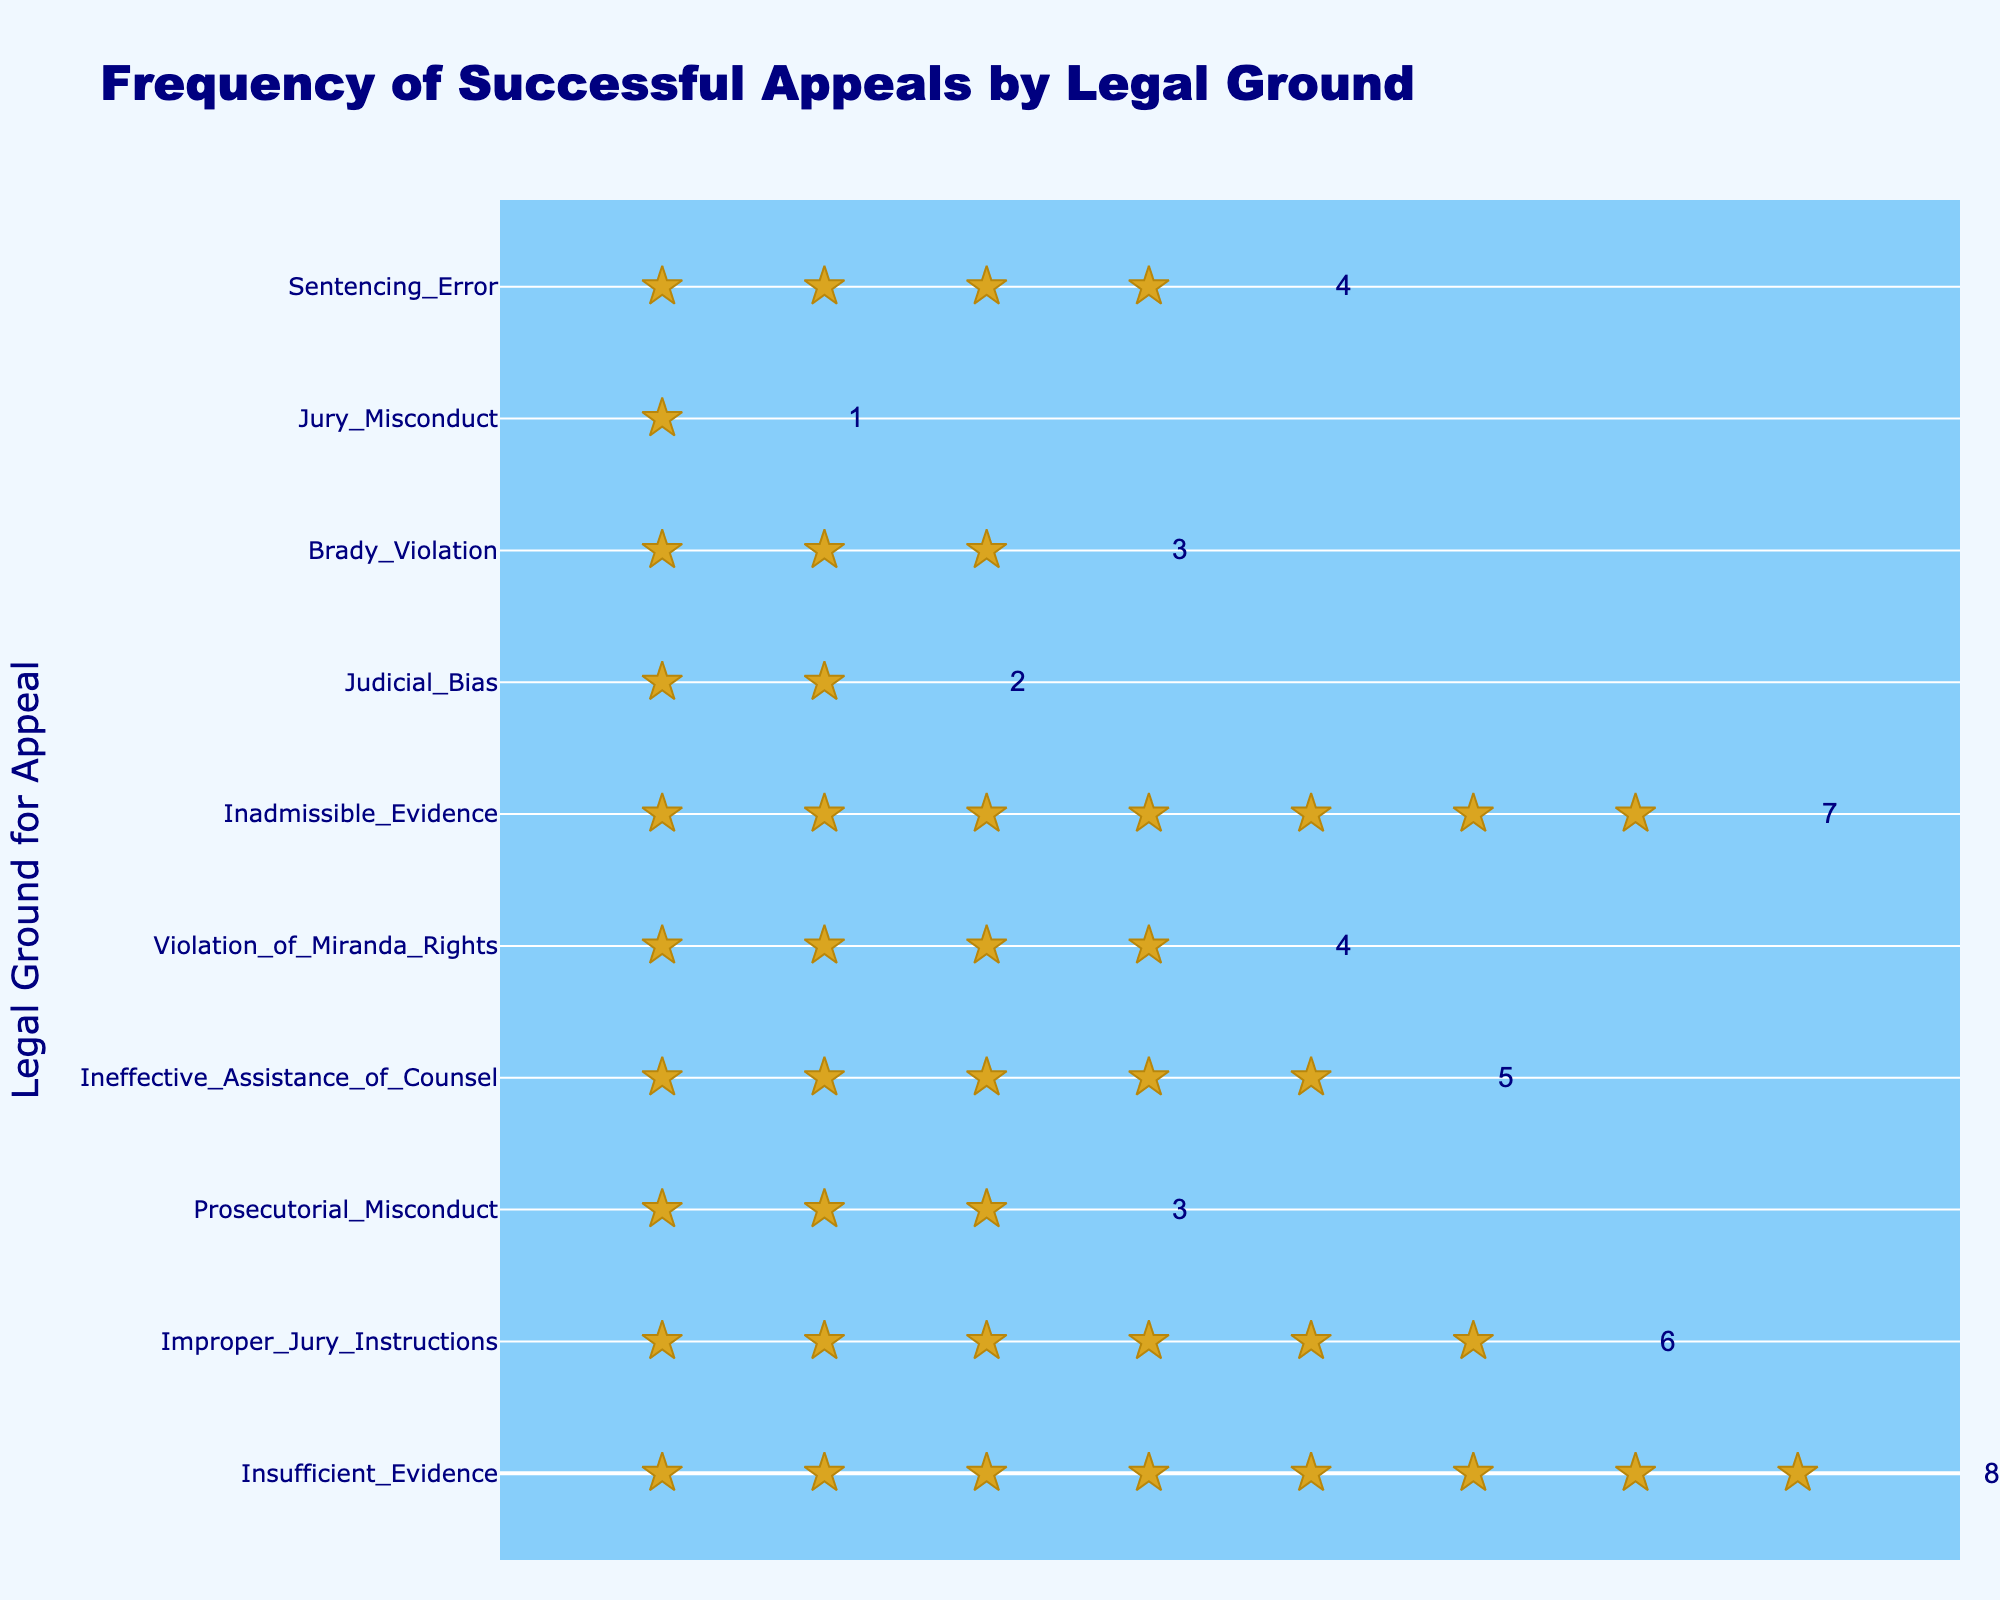What's the title of the figure? The title is usually found at the top of the figure. In this case, it reads "Frequency of Successful Appeals by Legal Ground."
Answer: Frequency of Successful Appeals by Legal Ground What is the legal ground with the highest number of successful appeals? By counting the stars for each legal ground, we see that "Insufficient Evidence" has the most, with 8 stars.
Answer: Insufficient Evidence How many successful appeals were made for "Prosecutorial Misconduct"? Look for the row labeled "Prosecutorial Misconduct" and count the number of stars in that row. There are 3 stars.
Answer: 3 Which legal ground has fewer successful appeals, "Jury Misconduct" or "Judicial Bias"? Compare the number of stars for "Jury Misconduct" and "Judicial Bias". "Jury Misconduct" has 1 star, and "Judicial Bias" has 2 stars, so "Jury Misconduct" has fewer successful appeals.
Answer: Jury Misconduct What is the total number of successful appeals across all legal grounds? Sum the number of stars for all the legal grounds: 8 + 6 + 3 + 5 + 4 + 7 + 2 + 3 + 1 + 4 = 43.
Answer: 43 Which legal grounds for appeal have an equal number of successful appeals? Compare the number of stars for each legal ground to find matches. "Prosecutorial Misconduct" and "Brady Violation" both have 3 stars. "Violation of Miranda Rights" and "Sentencing Error" both have 4 stars.
Answer: Prosecutorial Misconduct and Brady Violation; Violation of Miranda Rights and Sentencing Error What is the average number of successful appeals per legal ground? There are 10 legal grounds. The total number of successful appeals is 43. Therefore, the average is 43 / 10 = 4.3.
Answer: 4.3 Is "Inadmissible Evidence" more frequent than "Ineffective Assistance of Counsel" for successful appeals? Compare the number of stars. "Inadmissible Evidence" has 7 stars, while "Ineffective Assistance of Counsel" has 5 stars. Yes, "Inadmissible Evidence" is more frequent.
Answer: Yes Rank the top three legal grounds of successful appeals in descending order. From the number of stars: 1) Insufficient Evidence (8), 2) Inadmissible Evidence (7), 3) Improper Jury Instructions (6).
Answer: 1) Insufficient Evidence, 2) Inadmissible Evidence, 3) Improper Jury Instructions 